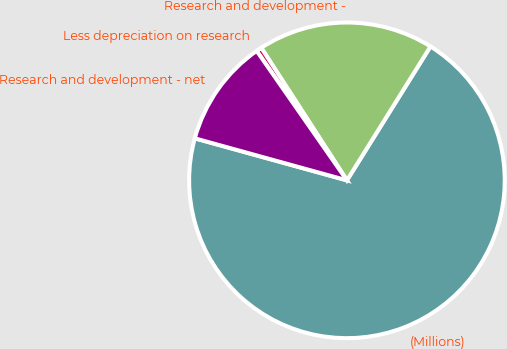Convert chart. <chart><loc_0><loc_0><loc_500><loc_500><pie_chart><fcel>(Millions)<fcel>Research and development -<fcel>Less depreciation on research<fcel>Research and development - net<nl><fcel>70.41%<fcel>18.01%<fcel>0.56%<fcel>11.02%<nl></chart> 